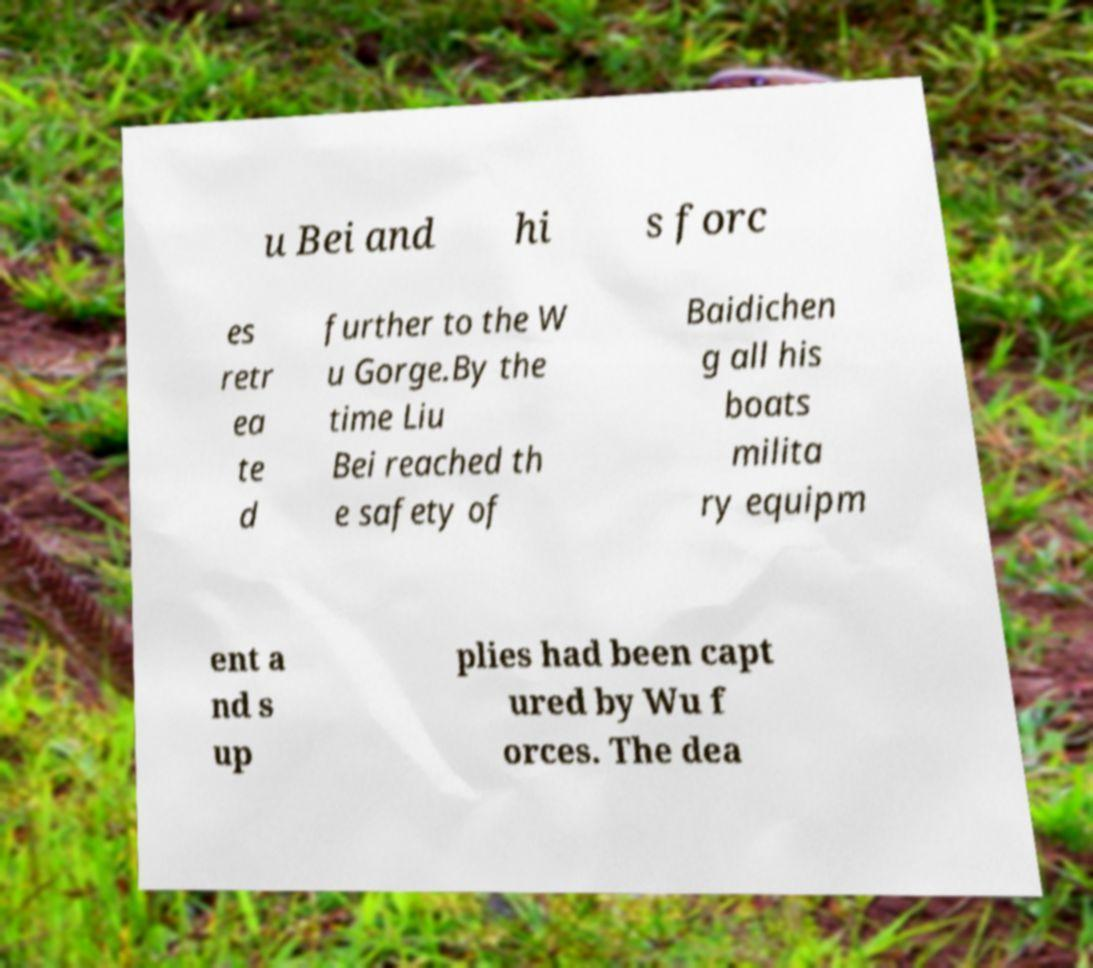For documentation purposes, I need the text within this image transcribed. Could you provide that? u Bei and hi s forc es retr ea te d further to the W u Gorge.By the time Liu Bei reached th e safety of Baidichen g all his boats milita ry equipm ent a nd s up plies had been capt ured by Wu f orces. The dea 